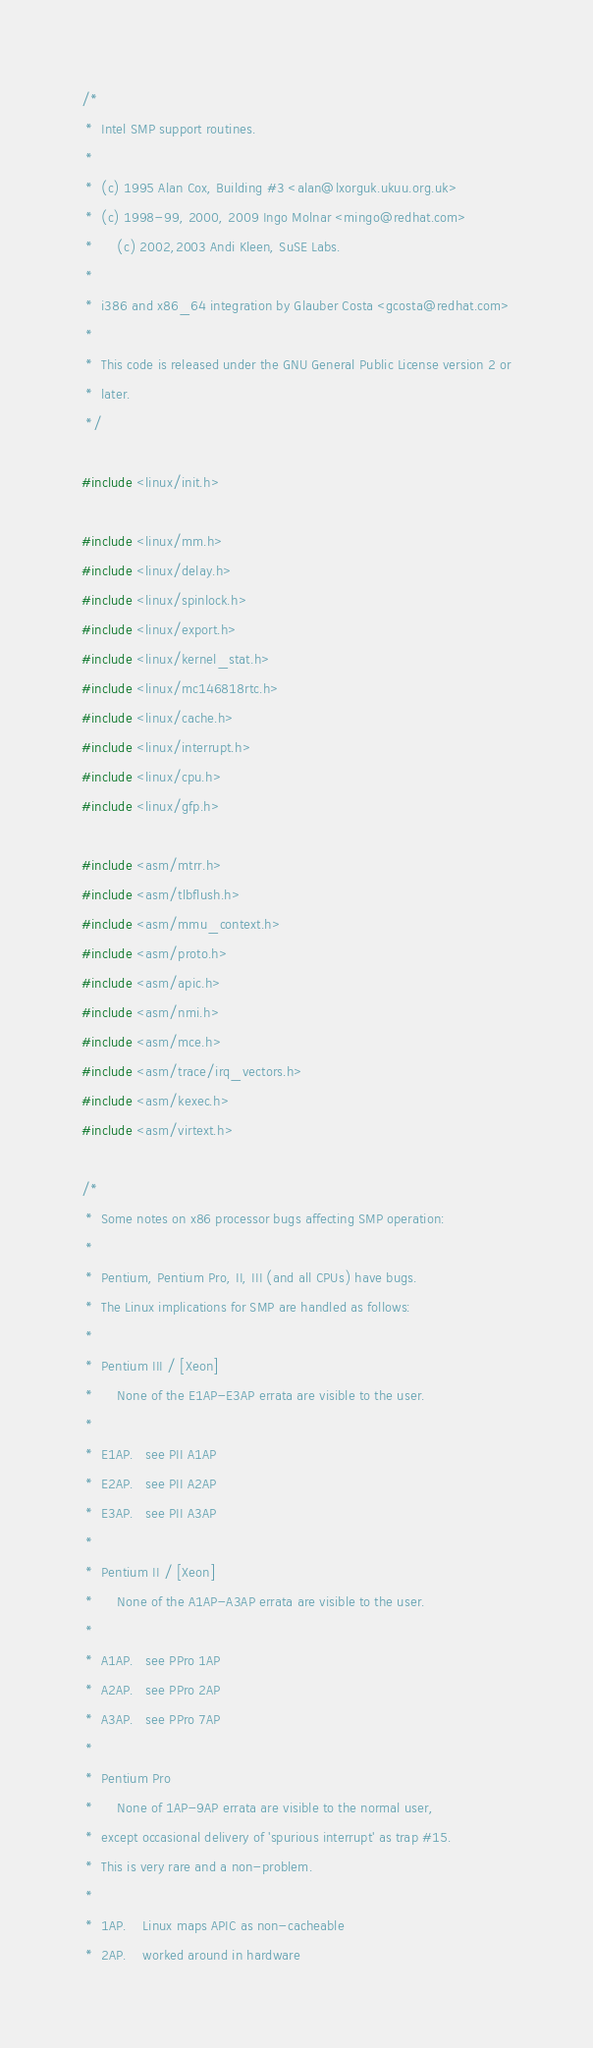Convert code to text. <code><loc_0><loc_0><loc_500><loc_500><_C_>/*
 *	Intel SMP support routines.
 *
 *	(c) 1995 Alan Cox, Building #3 <alan@lxorguk.ukuu.org.uk>
 *	(c) 1998-99, 2000, 2009 Ingo Molnar <mingo@redhat.com>
 *      (c) 2002,2003 Andi Kleen, SuSE Labs.
 *
 *	i386 and x86_64 integration by Glauber Costa <gcosta@redhat.com>
 *
 *	This code is released under the GNU General Public License version 2 or
 *	later.
 */

#include <linux/init.h>

#include <linux/mm.h>
#include <linux/delay.h>
#include <linux/spinlock.h>
#include <linux/export.h>
#include <linux/kernel_stat.h>
#include <linux/mc146818rtc.h>
#include <linux/cache.h>
#include <linux/interrupt.h>
#include <linux/cpu.h>
#include <linux/gfp.h>

#include <asm/mtrr.h>
#include <asm/tlbflush.h>
#include <asm/mmu_context.h>
#include <asm/proto.h>
#include <asm/apic.h>
#include <asm/nmi.h>
#include <asm/mce.h>
#include <asm/trace/irq_vectors.h>
#include <asm/kexec.h>
#include <asm/virtext.h>

/*
 *	Some notes on x86 processor bugs affecting SMP operation:
 *
 *	Pentium, Pentium Pro, II, III (and all CPUs) have bugs.
 *	The Linux implications for SMP are handled as follows:
 *
 *	Pentium III / [Xeon]
 *		None of the E1AP-E3AP errata are visible to the user.
 *
 *	E1AP.	see PII A1AP
 *	E2AP.	see PII A2AP
 *	E3AP.	see PII A3AP
 *
 *	Pentium II / [Xeon]
 *		None of the A1AP-A3AP errata are visible to the user.
 *
 *	A1AP.	see PPro 1AP
 *	A2AP.	see PPro 2AP
 *	A3AP.	see PPro 7AP
 *
 *	Pentium Pro
 *		None of 1AP-9AP errata are visible to the normal user,
 *	except occasional delivery of 'spurious interrupt' as trap #15.
 *	This is very rare and a non-problem.
 *
 *	1AP.	Linux maps APIC as non-cacheable
 *	2AP.	worked around in hardware</code> 